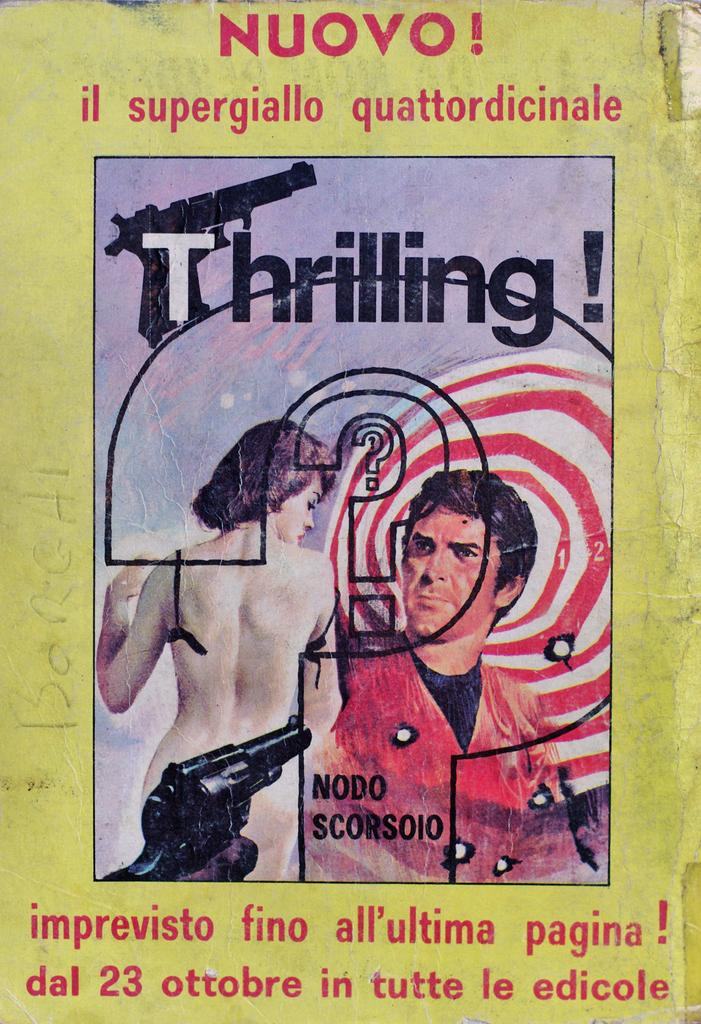What is present in the image that contains information or a message? There is a poster in the image that contains text. What else can be seen on the poster besides the text? There are people depicted in the poster. What type of tin can be seen in the image? There is no tin present in the image. What does the mom in the image say to the people depicted? There is no mom or dialogue present in the image. 